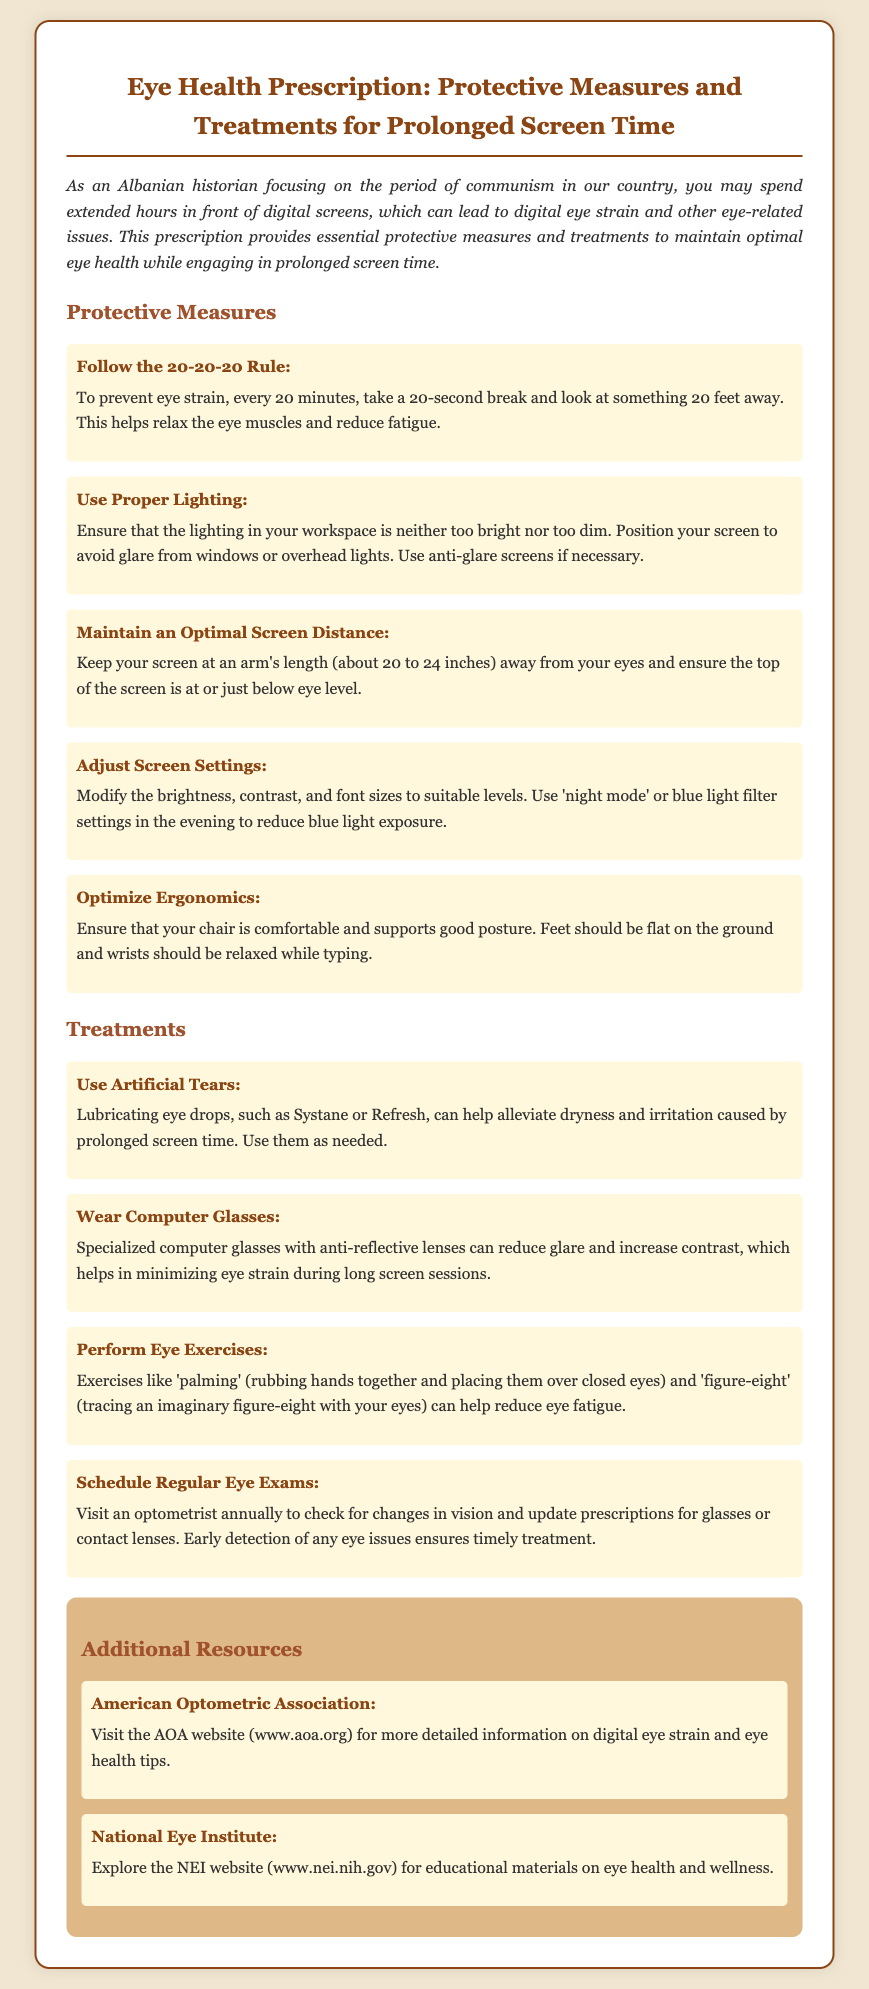what is the title of the document? The title of the document is stated at the top and describes the focus on eye health.
Answer: Eye Health Prescription: Protective Measures and Treatments for Prolonged Screen Time what is the 20-20-20 rule? The 20-20-20 rule is mentioned as a protective measure to reduce eye strain.
Answer: Take a 20-second break and look at something 20 feet away what should be the optimal screen distance? The document specifies the recommended distance for placing the screen from your eyes.
Answer: About 20 to 24 inches what type of eye drops are recommended for dryness? The document discusses treatments for dry eyes caused by screen time.
Answer: Lubricating eye drops, such as Systane or Refresh how often should one schedule eye exams? The document recommends a frequency for eye exams to monitor vision changes.
Answer: Annually what is a suggested treatment for eye strain? The document lists various treatments to alleviate eye strain from screen use.
Answer: Use Artificial Tears which organization provides more information on digital eye strain? The document includes resources for further information on eye health.
Answer: American Optometric Association what ergonomic aspect should be maintained while typing? The document emphasizes certain ergonomic practices while using screens.
Answer: Wrists should be relaxed while typing what should you ensure about screen brightness? The document mentions a specific consideration regarding screen brightness in the workspace.
Answer: Ensure that the lighting is neither too bright nor too dim 